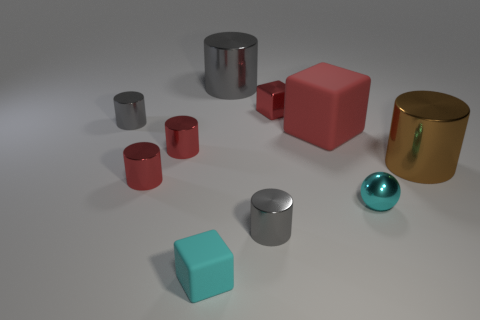There is a large red object that is the same shape as the cyan rubber thing; what is it made of?
Your answer should be compact. Rubber. There is a tiny block to the right of the large gray metal cylinder on the left side of the brown object; what number of big matte things are behind it?
Your answer should be compact. 0. Is there any other thing of the same color as the metallic sphere?
Offer a terse response. Yes. How many objects are both in front of the brown cylinder and on the left side of the tiny cyan metallic object?
Offer a terse response. 3. Do the rubber block that is on the right side of the big gray cylinder and the brown thing that is on the right side of the big red rubber object have the same size?
Keep it short and to the point. Yes. How many objects are cyan shiny spheres that are in front of the big gray shiny thing or large red matte things?
Provide a succinct answer. 2. What is the small cyan object on the right side of the tiny cyan matte block made of?
Your answer should be very brief. Metal. What material is the brown cylinder?
Your response must be concise. Metal. What material is the red block that is in front of the red shiny object on the right side of the rubber cube in front of the big red block made of?
Your answer should be compact. Rubber. Is there anything else that has the same material as the brown thing?
Provide a short and direct response. Yes. 